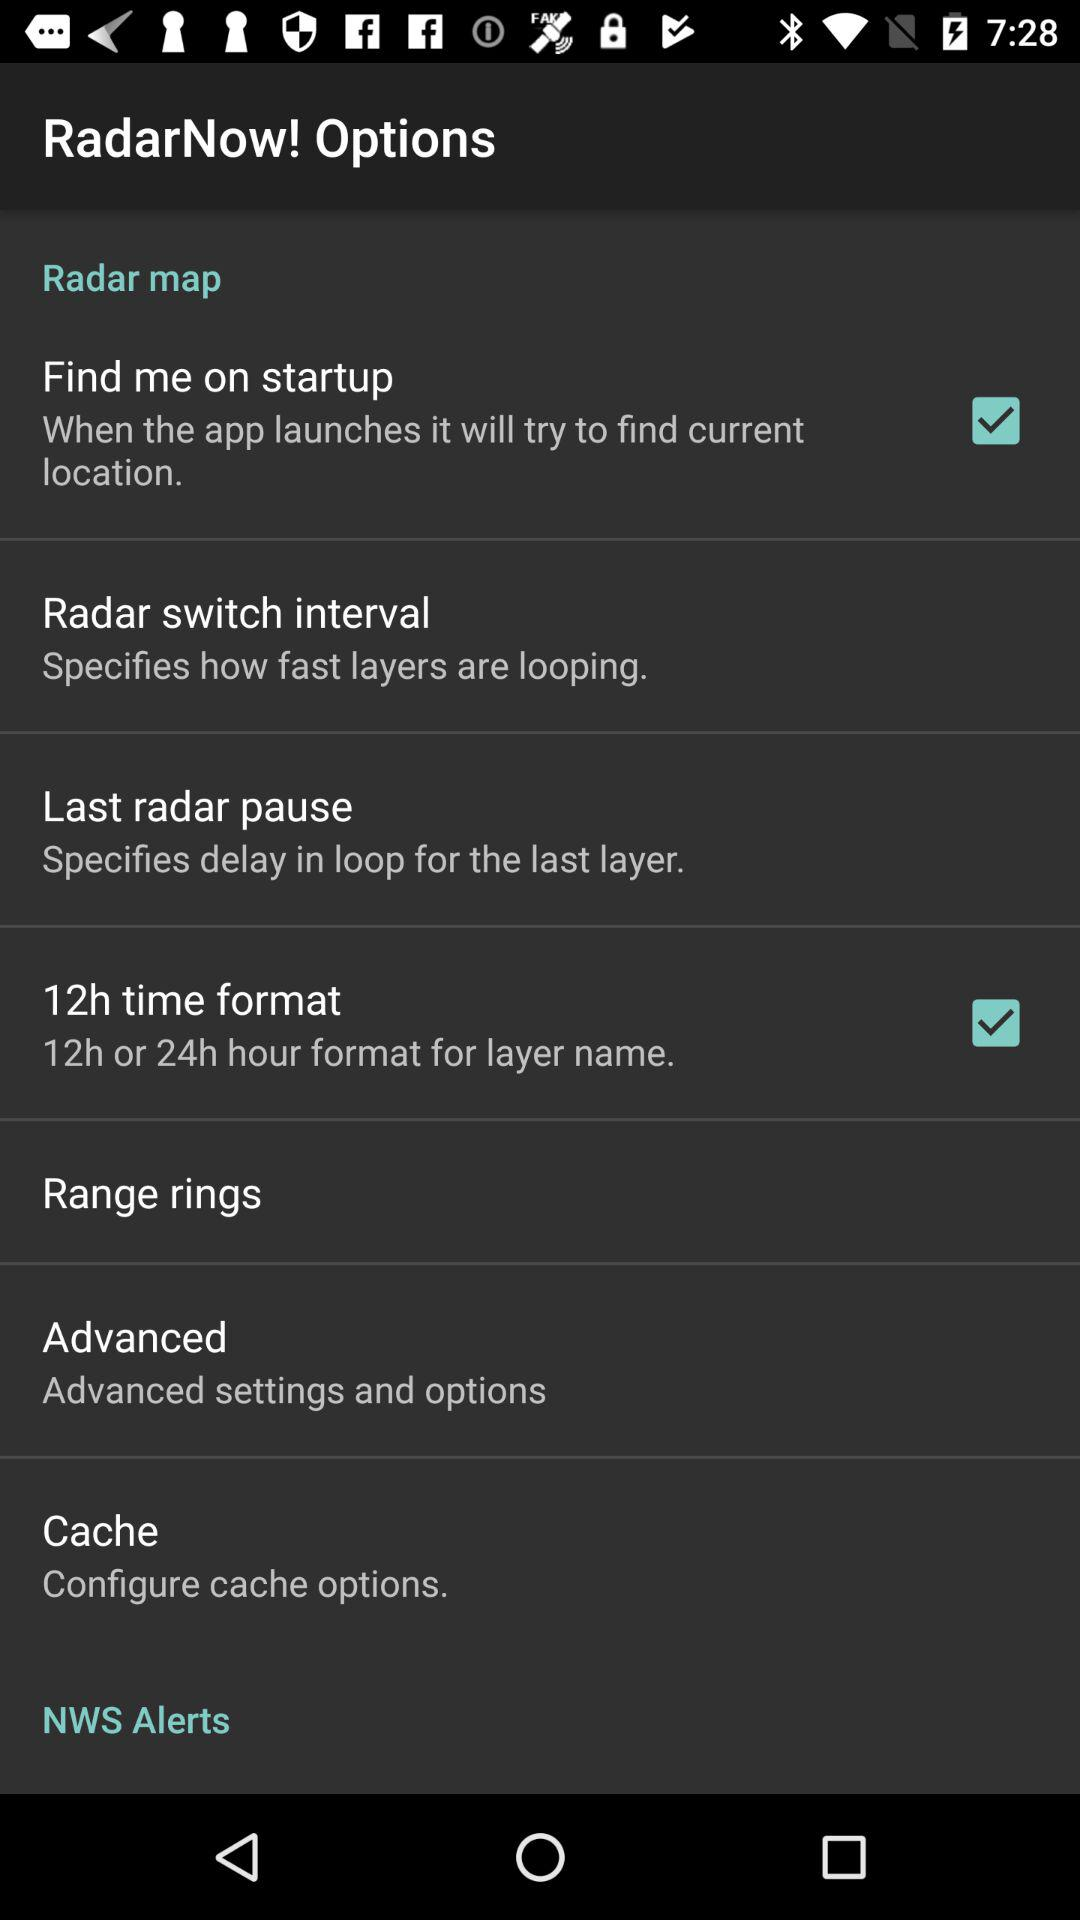Which settings and options are available in "Advanced"?
When the provided information is insufficient, respond with <no answer>. <no answer> 